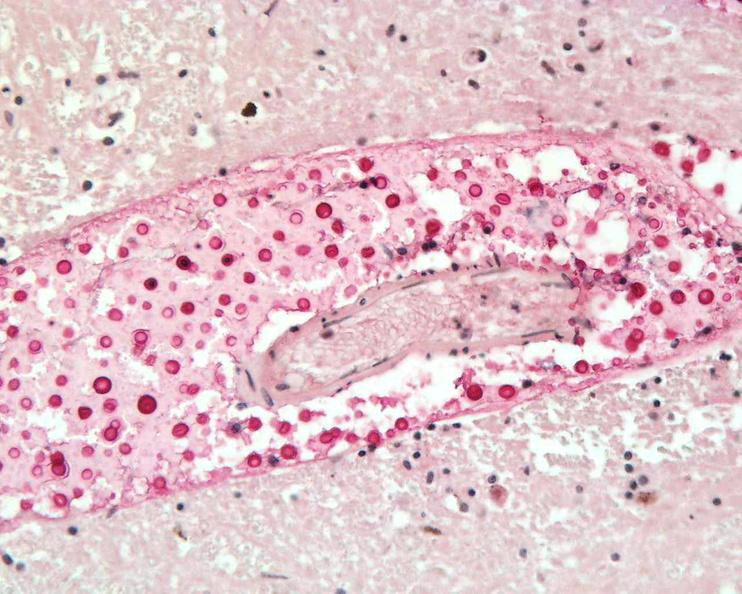where is this?
Answer the question using a single word or phrase. Nervous 